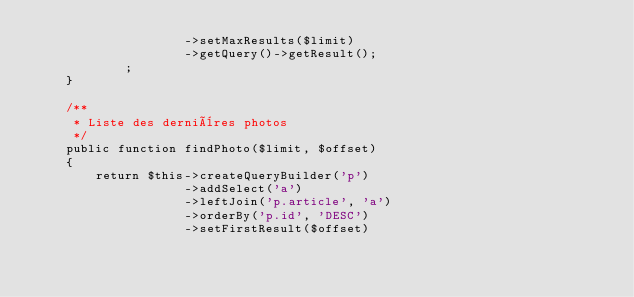Convert code to text. <code><loc_0><loc_0><loc_500><loc_500><_PHP_>                    ->setMaxResults($limit)
                    ->getQuery()->getResult();
            ;
    }

    /**
     * Liste des dernières photos
     */
    public function findPhoto($limit, $offset)
    {
        return $this->createQueryBuilder('p')
                    ->addSelect('a')
                    ->leftJoin('p.article', 'a')
                    ->orderBy('p.id', 'DESC')
                    ->setFirstResult($offset)</code> 